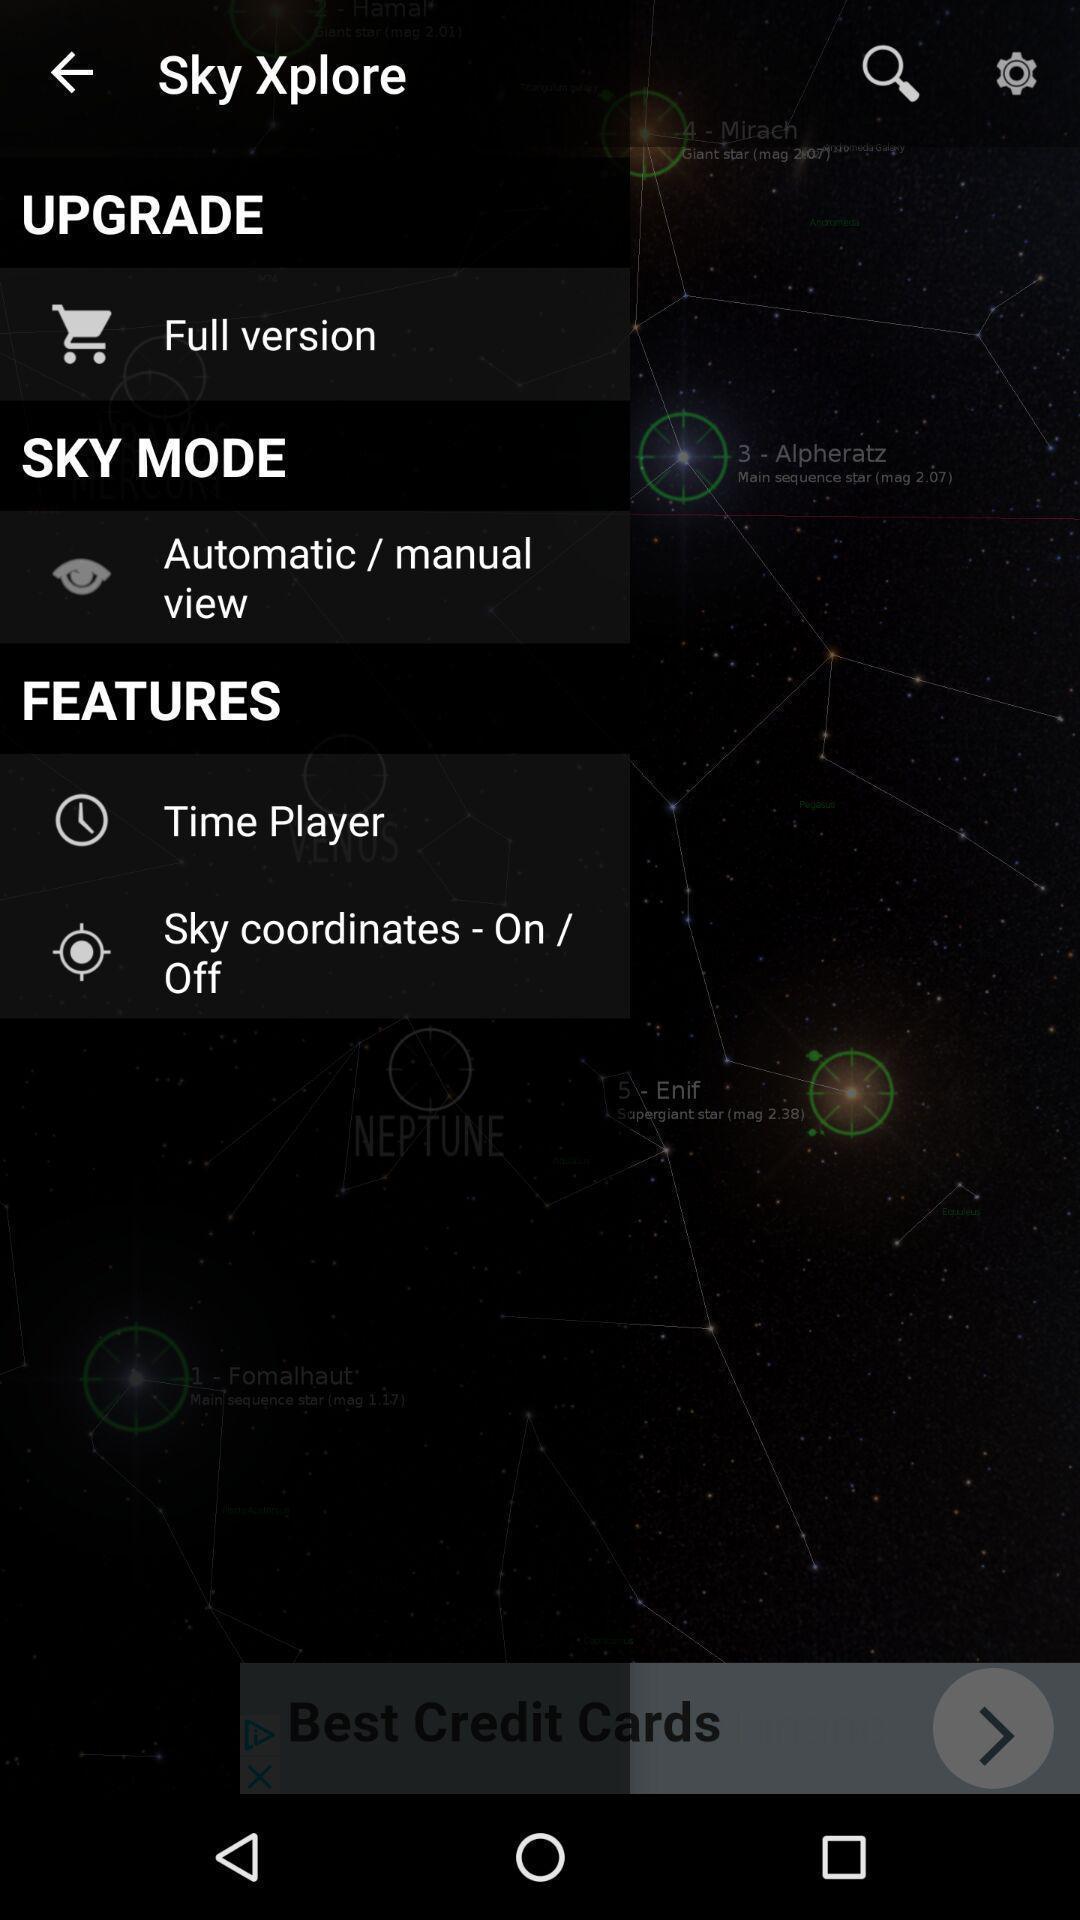Provide a textual representation of this image. Popup slide with list of options. 